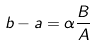<formula> <loc_0><loc_0><loc_500><loc_500>b - a = \alpha \frac { B } { A }</formula> 